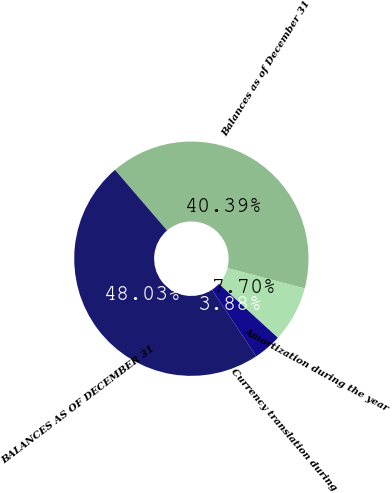Convert chart. <chart><loc_0><loc_0><loc_500><loc_500><pie_chart><fcel>Balances as of December 31<fcel>Amortization during the year<fcel>Currency translation during<fcel>BALANCES AS OF DECEMBER 31<nl><fcel>40.39%<fcel>7.7%<fcel>3.88%<fcel>48.03%<nl></chart> 